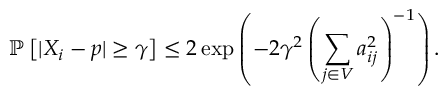Convert formula to latex. <formula><loc_0><loc_0><loc_500><loc_500>\mathbb { P } \left [ | X _ { i } - p | \geq \gamma \right ] \leq 2 \exp \left ( - 2 \gamma ^ { 2 } \left ( \sum _ { j \in V } a _ { i j } ^ { 2 } \right ) ^ { - 1 } \right ) .</formula> 